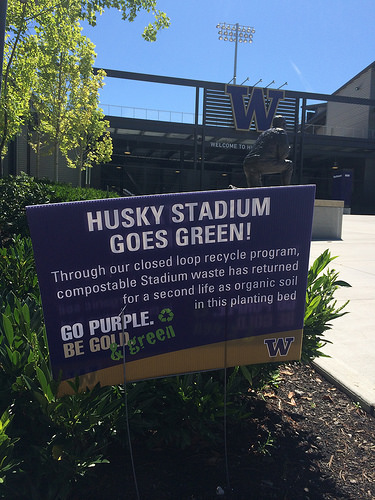<image>
Is there a board in the meadow? No. The board is not contained within the meadow. These objects have a different spatial relationship. 